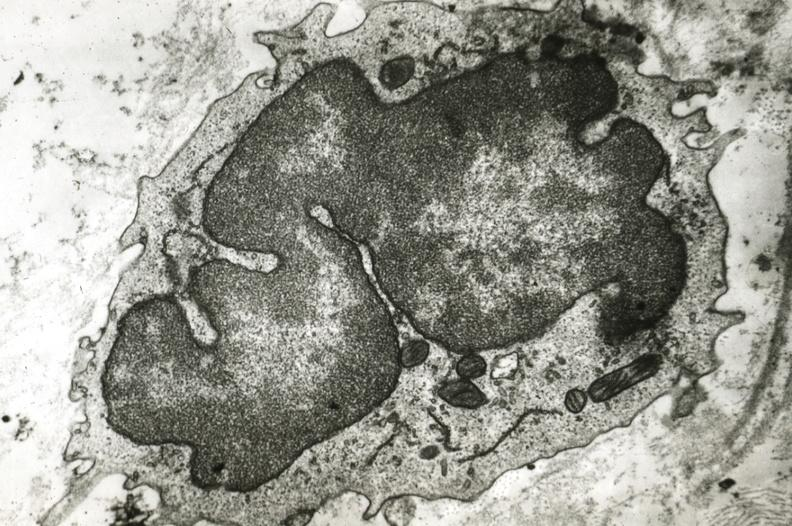s coronary artery present?
Answer the question using a single word or phrase. Yes 